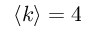Convert formula to latex. <formula><loc_0><loc_0><loc_500><loc_500>\langle k \rangle = 4</formula> 